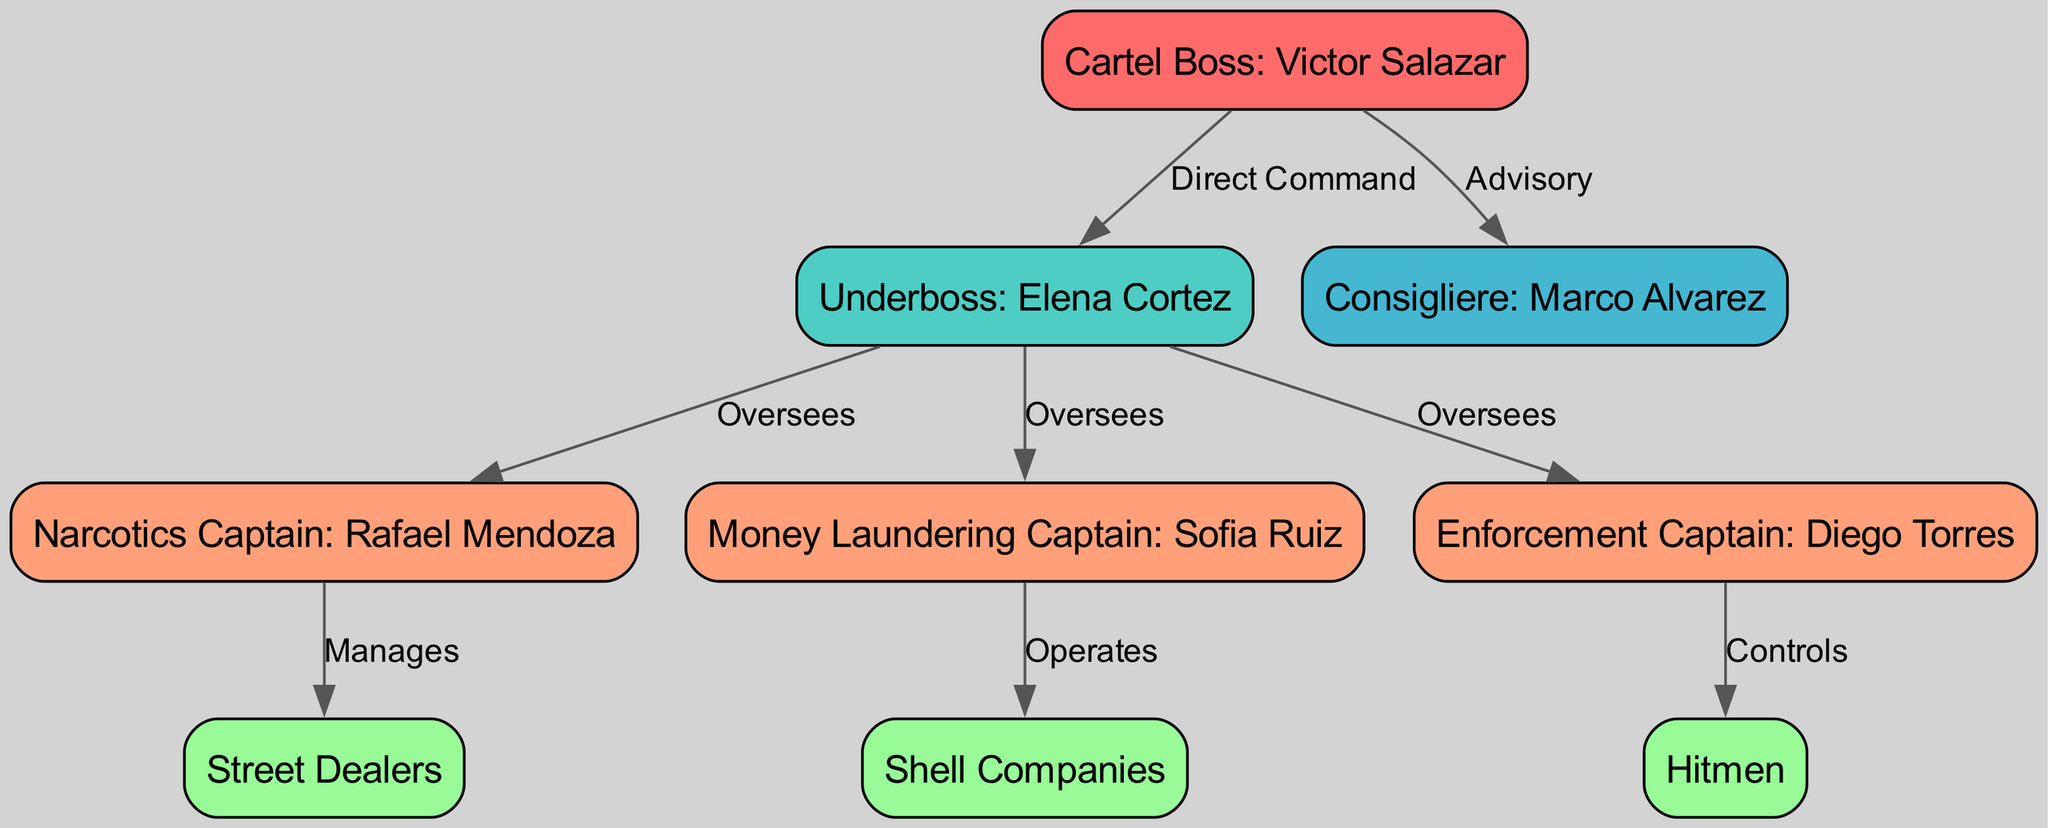What is the title of the top node in the hierarchy? The top node represents the highest authority in the organization, which in this case is the "Cartel Boss: Victor Salazar." Since this is indicated as the first node in the diagram, we can directly refer to its label as the answer.
Answer: Cartel Boss: Victor Salazar How many total nodes are in the diagram? Each node represents a specific player or role within the criminal organization. By counting each unique node provided in the data, we determine that there are a total of nine nodes.
Answer: 9 What is the relationship between the Underboss and the Narcotics Captain? The Underboss, "Elena Cortez," has a supervisory role over the Narcotics Captain, as indicated by the "Oversees" label connecting them. This relationship shows that the Underboss is directly in command of the narcotics operations.
Answer: Oversees Who does the Enforcement Captain control? Referring to the hierarchical structure, the Enforcement Captain, "Diego Torres," has direct control over the "Hitmen." This can be confirmed by locating the edge that connects these two nodes labeled "Controls."
Answer: Hitmen Which node directly advises the Cartel Boss? The "Consigliere: Marco Alvarez" is the node that provides advisory support to the Cartel Boss, as indicated by the "Advisory" label between these two nodes. This shows the supportive role of the Consigliere in decision-making.
Answer: Consigliere: Marco Alvarez How many layers are present in the diagram hierarchy? By analyzing the layout of the nodes, we can identify three distinct layers: the top layer consists of the Cartel Boss, the middle layer includes the Underboss and Consigliere, and the lower layer contains the Captains, Street Dealers, Shell Companies, and Hitmen. Therefore, the hierarchy is composed of three layers.
Answer: 3 What role does the Money Laundering Captain operate through? The Money Laundering Captain, "Sofia Ruiz," operates through "Shell Companies," as represented by the connecting edge labeled "Operates." This connection indicates how money laundering activities are facilitated within the organization.
Answer: Shell Companies Who directly manages the Street Dealers? The Street Dealers are managed by the Narcotics Captain, "Rafael Mendoza," as denoted in the diagram with the label "Manages." This relationship clarifies the operational flow of street-level drug distribution within the organization.
Answer: Narcotics Captain: Rafael Mendoza What is the relationship between the Underboss and the Money Laundering Captain? The Underboss, "Elena Cortez," oversees the Money Laundering Captain, "Sofia Ruiz," highlighting a direct supervisory relationship indicated by the "Oversees" label connecting them. This reflects the Underboss's role in regulating money laundering operations.
Answer: Oversees 